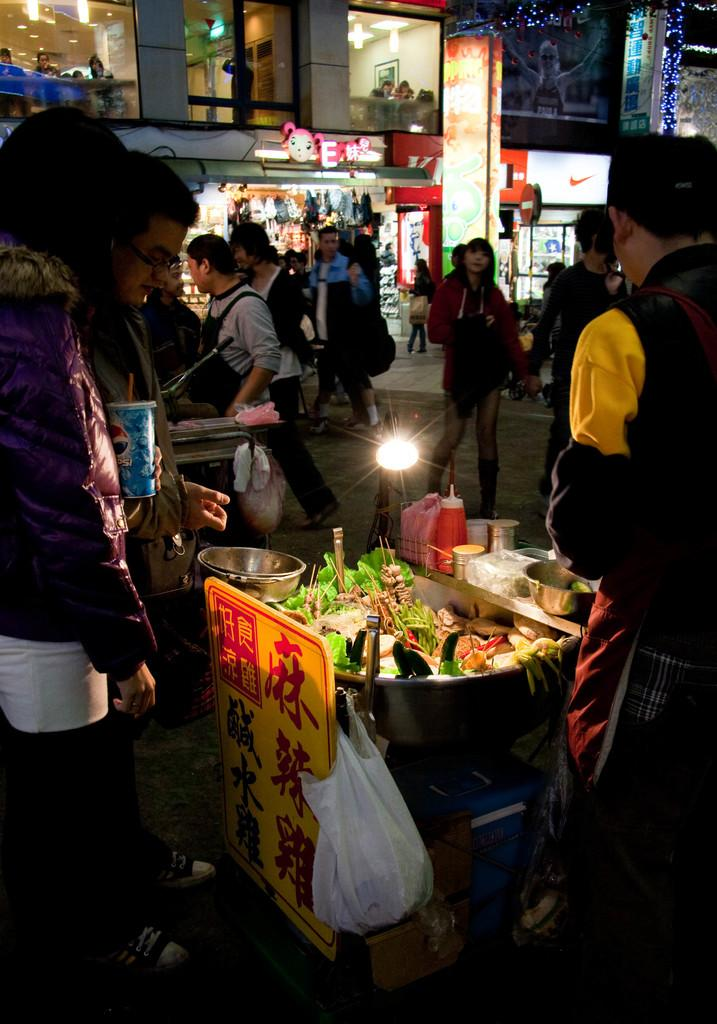What is happening on the street in the image? There are people on the street, and food is being sold. What type of establishments can be seen in the image? There are shops in the image. Can you describe the person holding an object? There is a person holding an object, but the specific object is not mentioned in the facts. What type of oatmeal is being served in the image? There is no mention of oatmeal being served in the image. Can you describe the bears that are walking on the street? There are no bears present in the image. 